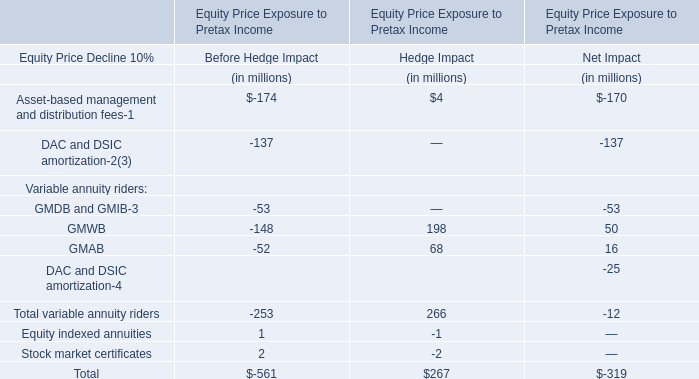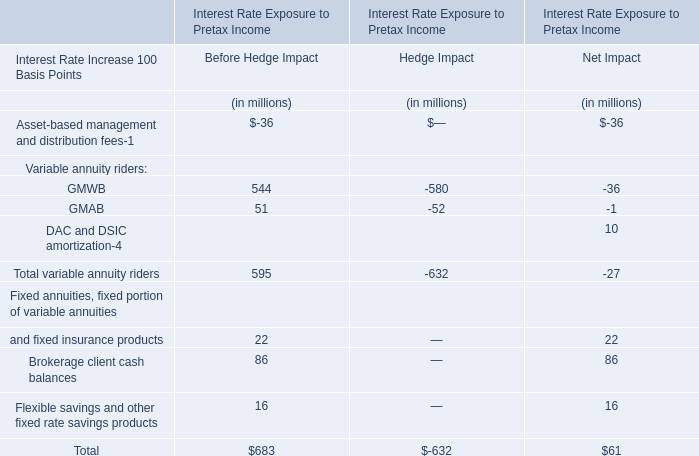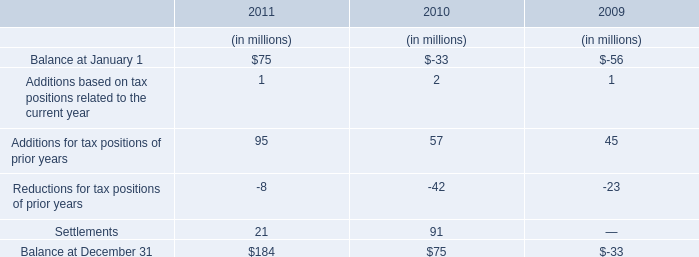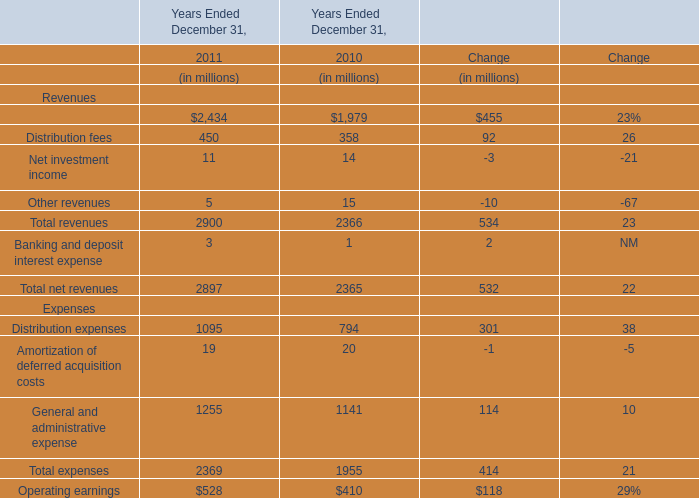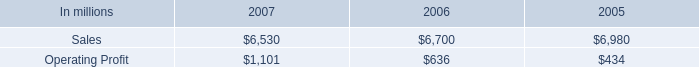What's the greatest value of expenses in 2011? (in millions) 
Answer: 1255. 